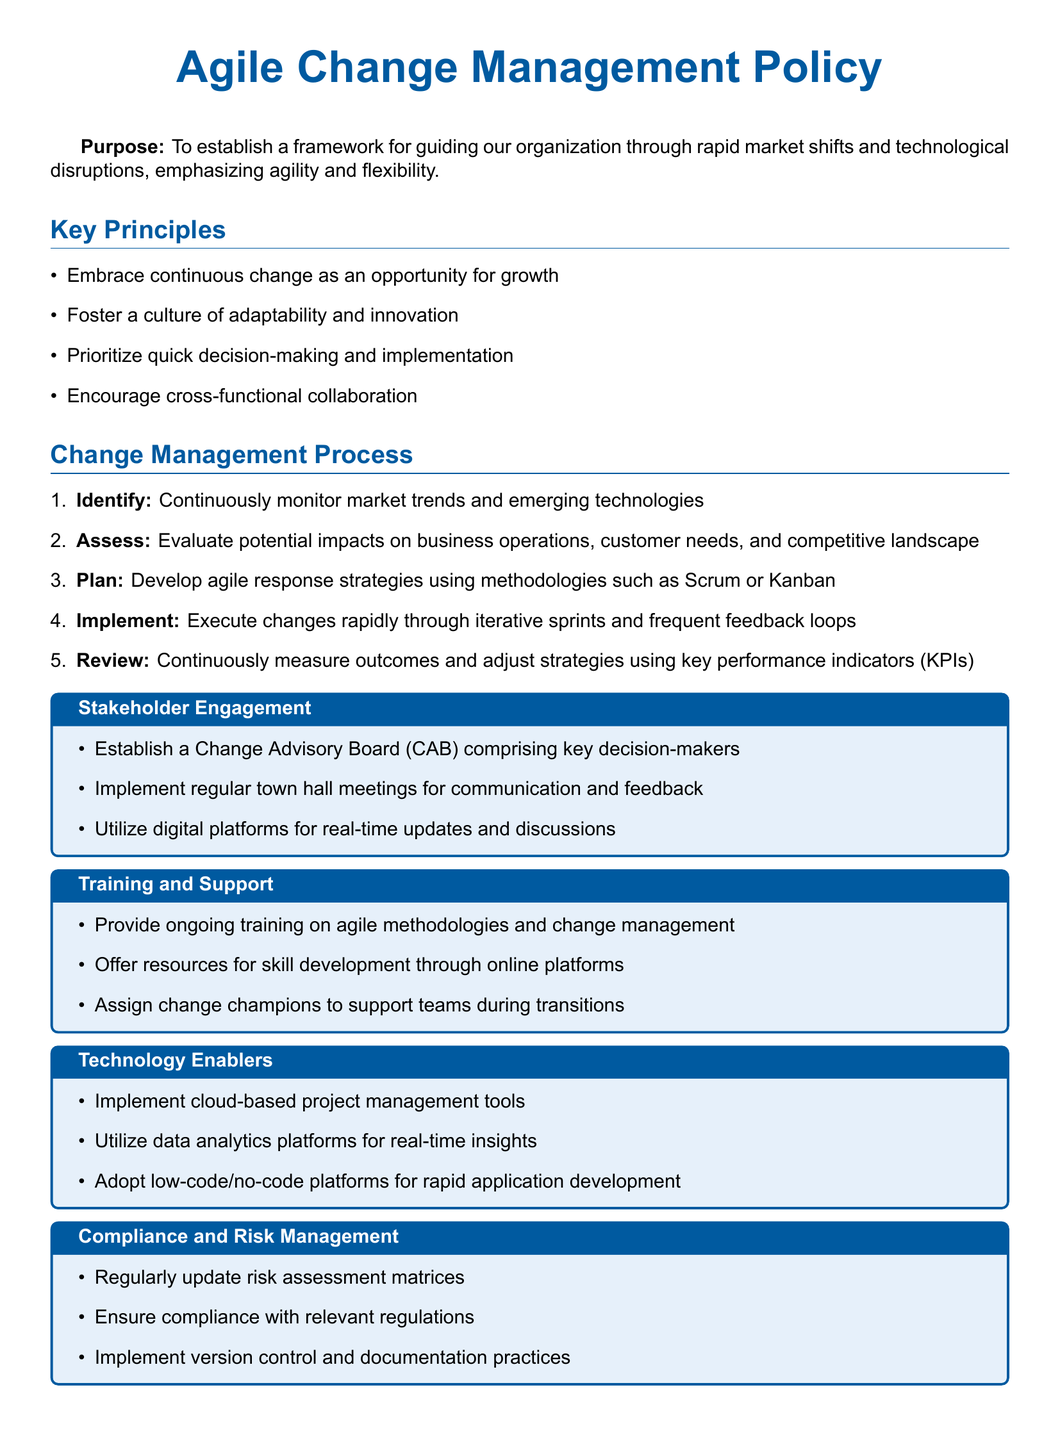What is the purpose of the Agile Change Management Policy? The purpose is to establish a framework for guiding the organization through rapid market shifts and technological disruptions, emphasizing agility and flexibility.
Answer: To establish a framework for guiding our organization through rapid market shifts and technological disruptions, emphasizing agility and flexibility What is the first step in the Change Management Process? The first step in the process is stated explicitly in the document.
Answer: Identify How many key principles are listed in the document? The document includes a list of key principles, which can be counted.
Answer: Four What is the role of the Change Advisory Board? The document states the board comprises key decision-makers involved in the change process.
Answer: Comprising key decision-makers Which agile methodologies are mentioned for developing response strategies? The document specifies methodologies used in planning.
Answer: Scrum or Kanban What technology is suggested for real-time insights? The document mentions a specific type of platform for insights.
Answer: Data analytics platforms How often should the risk assessment matrices be updated? The document indicates the frequency of updates required for compliance.
Answer: Regularly What type of meetings are implemented for communication and feedback? The document describes the type of meetings held for stakeholder engagement.
Answer: Town hall meetings Who are assigned to support teams during transitions? The document refers to specific roles for supporting teams.
Answer: Change champions 